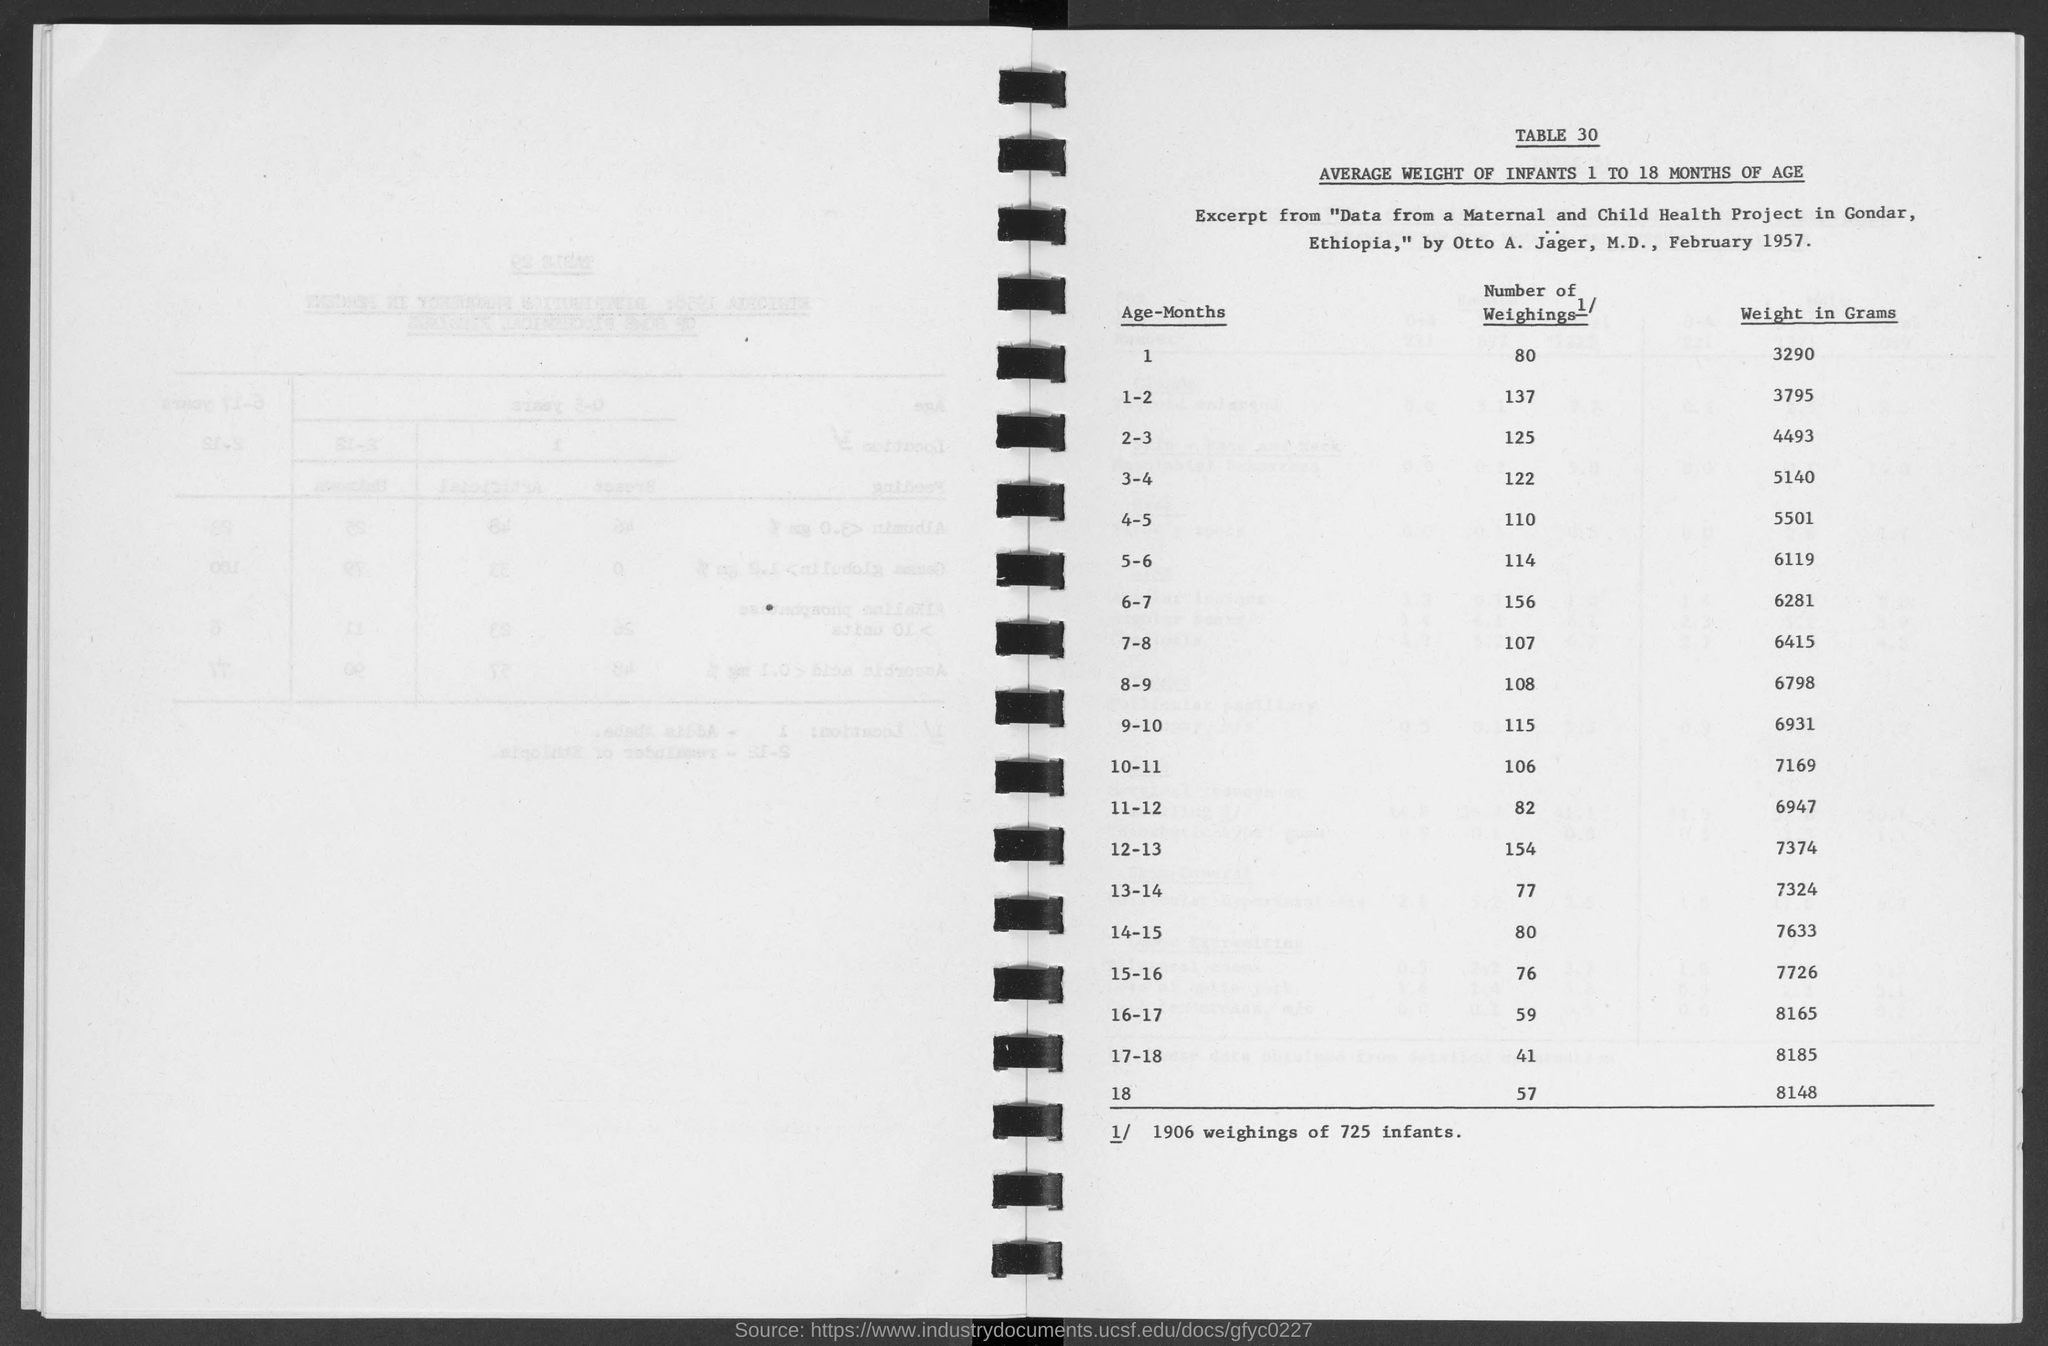Draw attention to some important aspects in this diagram. The average weight for infants in the age group 2-3 is approximately 4,493 grams. The number of weighings for infants in the age group 7-8 is 107. The average weight in grams for infants in the age group 11-12 is 6947 grams. A total of 114 weighings were performed on infants in the age group of 5-6. The average weight in grams for infants in the age group 5-6 is approximately 6119 grams. 